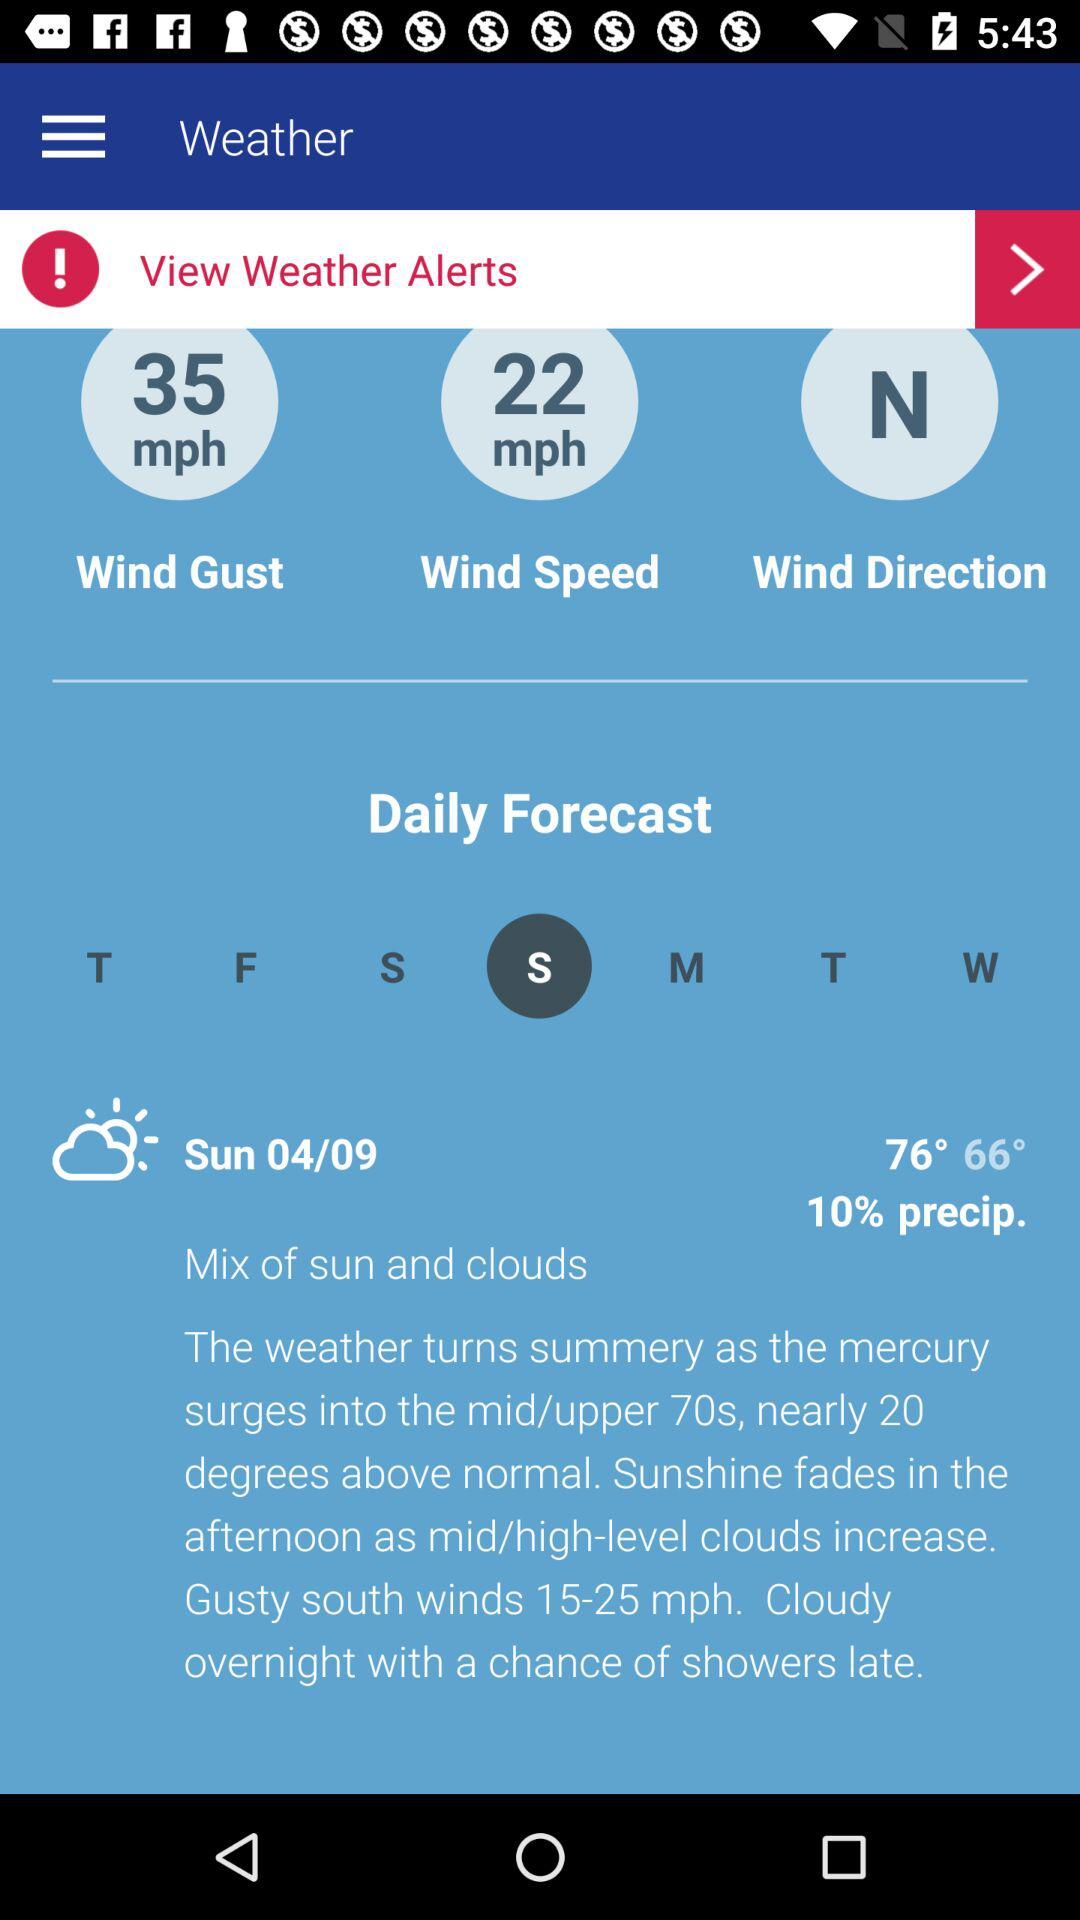What's the weather on 04/09? The weather is a mix of sun and clouds. 